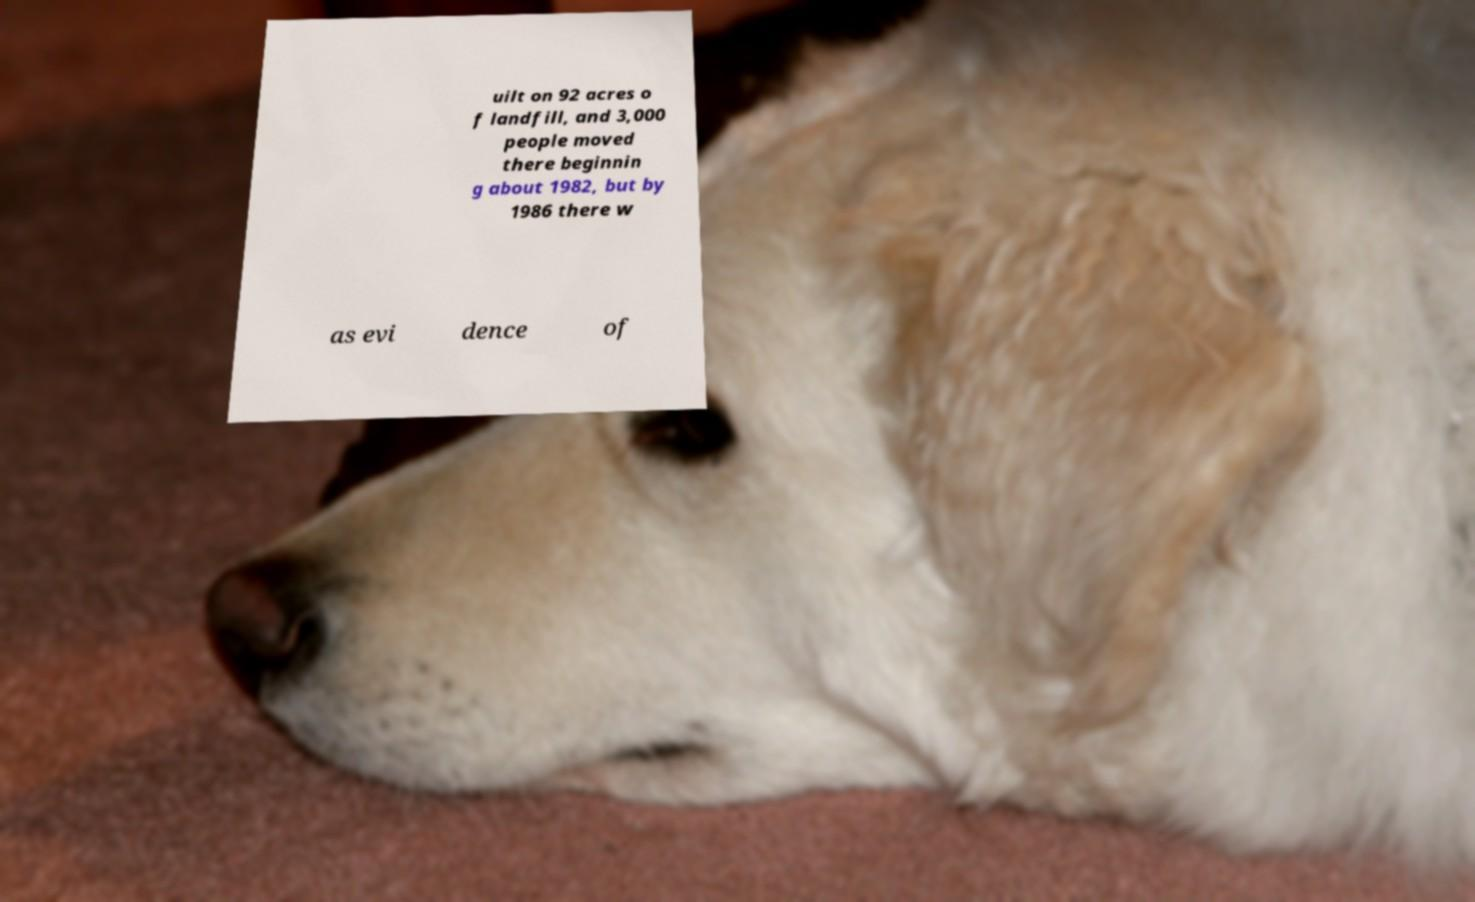For documentation purposes, I need the text within this image transcribed. Could you provide that? uilt on 92 acres o f landfill, and 3,000 people moved there beginnin g about 1982, but by 1986 there w as evi dence of 